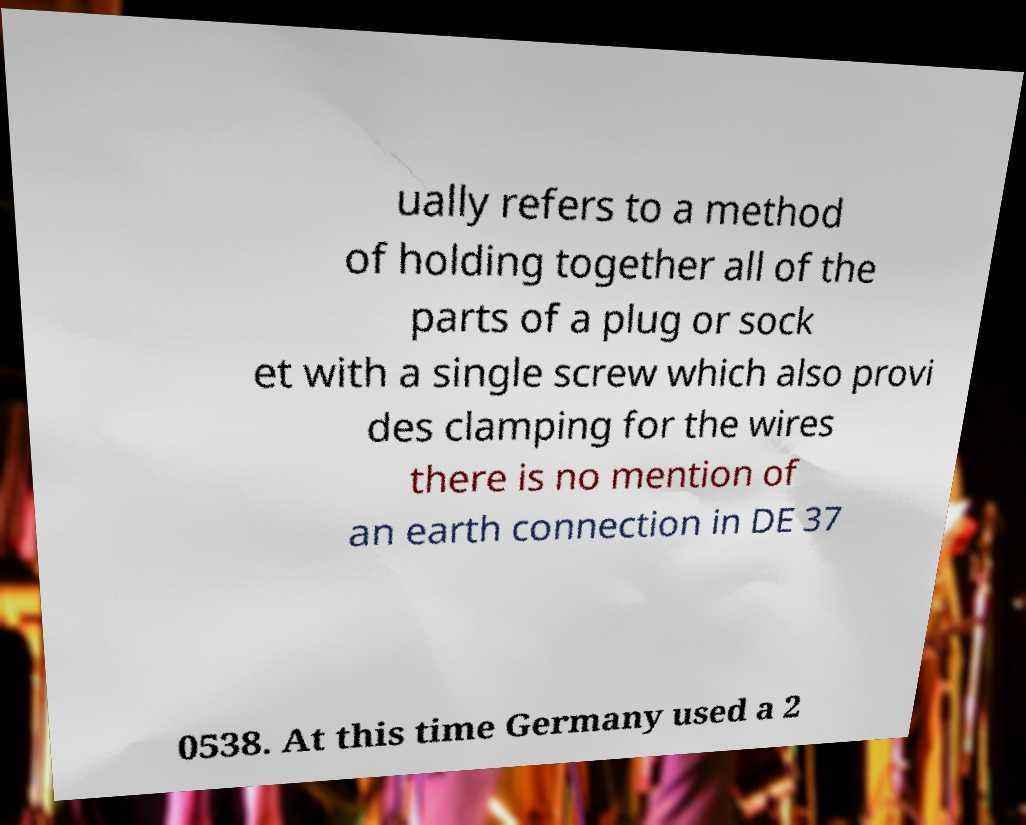Can you accurately transcribe the text from the provided image for me? ually refers to a method of holding together all of the parts of a plug or sock et with a single screw which also provi des clamping for the wires there is no mention of an earth connection in DE 37 0538. At this time Germany used a 2 